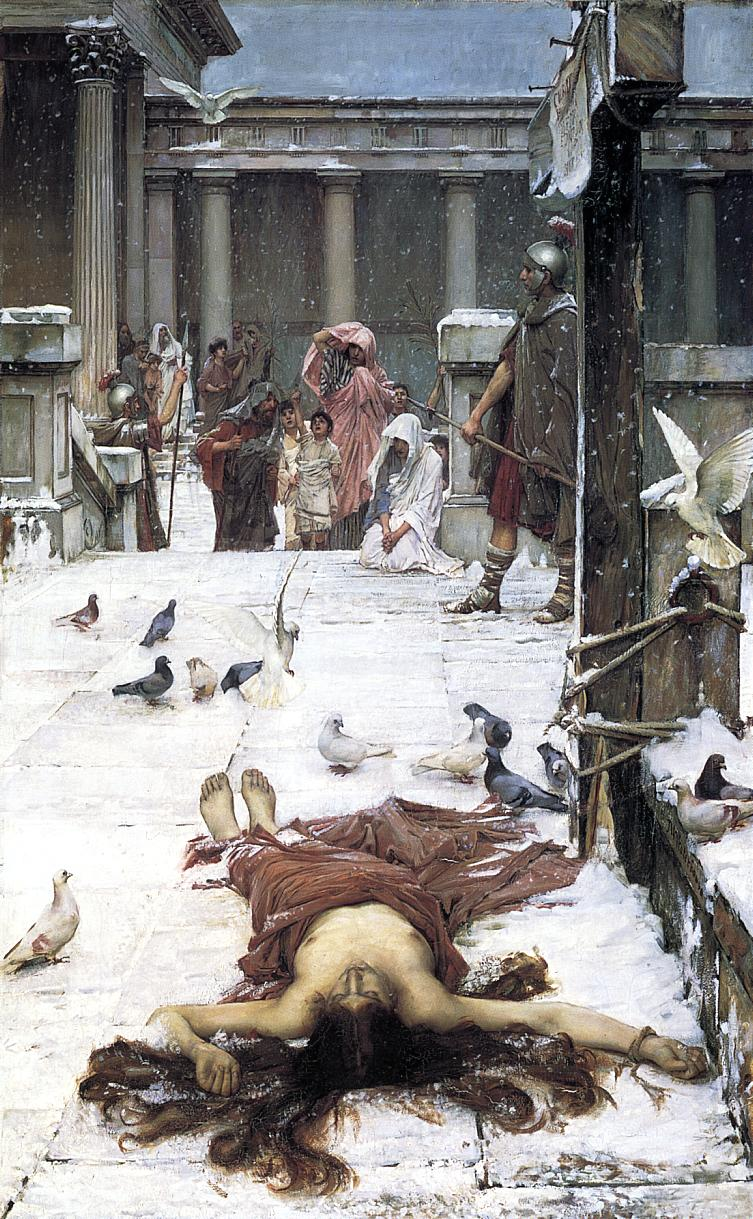What can you infer about this society based on the clothing and setting depicted? The clothing and architectural elements in the painting suggest a society with strong Roman influences, highlighting hierarchical structures and cultural richness. The varied attire, from the guards' armored outfits to the civilians' flowing robes, reflects a social stratification and a division of roles within this society. The grand columns and stone steps imply a setting of significance, possibly a place of governance or justice, hinting at the societal values and the importance of public life in this culture. 